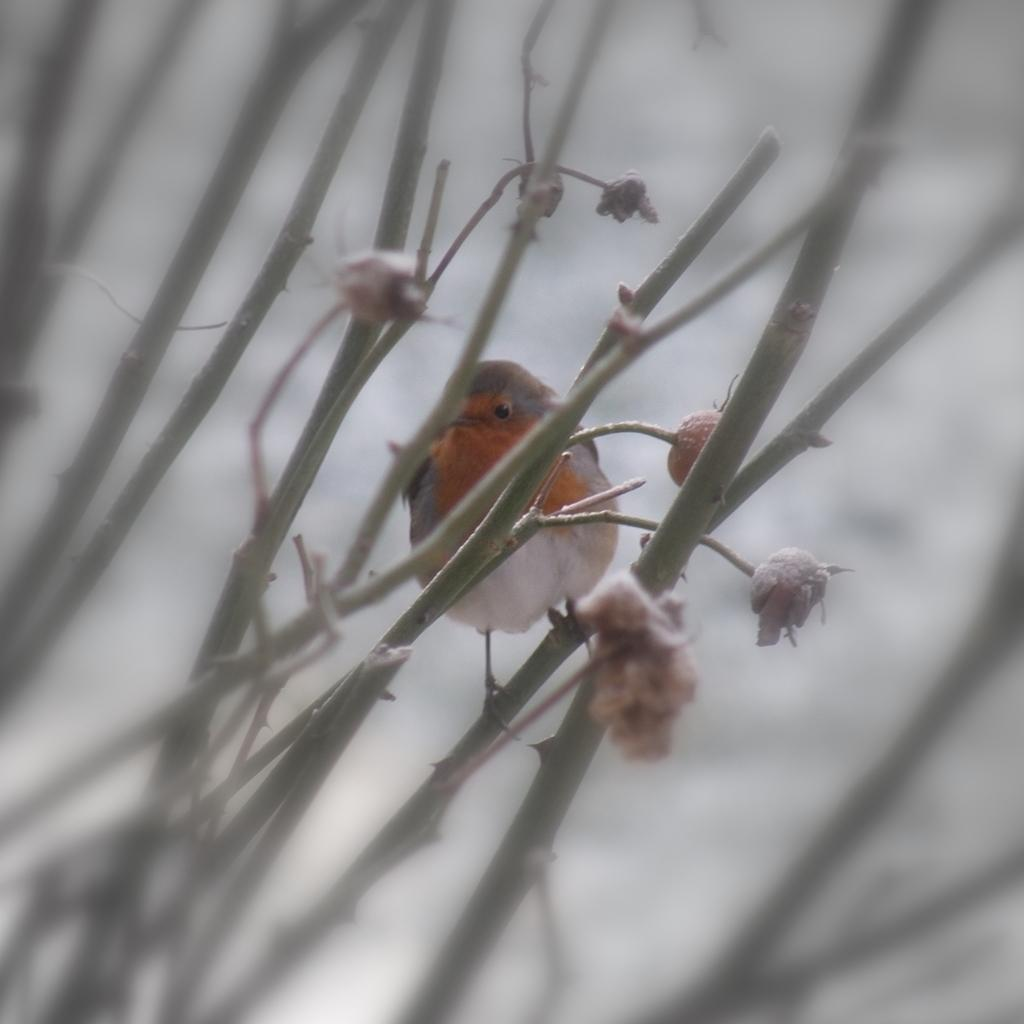What type of animal can be seen in the image? There is a bird in the image. Where is the bird located? The bird is on a branch in the image. What other elements can be seen in the image besides the bird? There are flowers, stems, and branches in the image. What type of quill is the bird using to write a note in the image? There is no quill or writing activity present in the image; the bird is simply perched on a branch. 